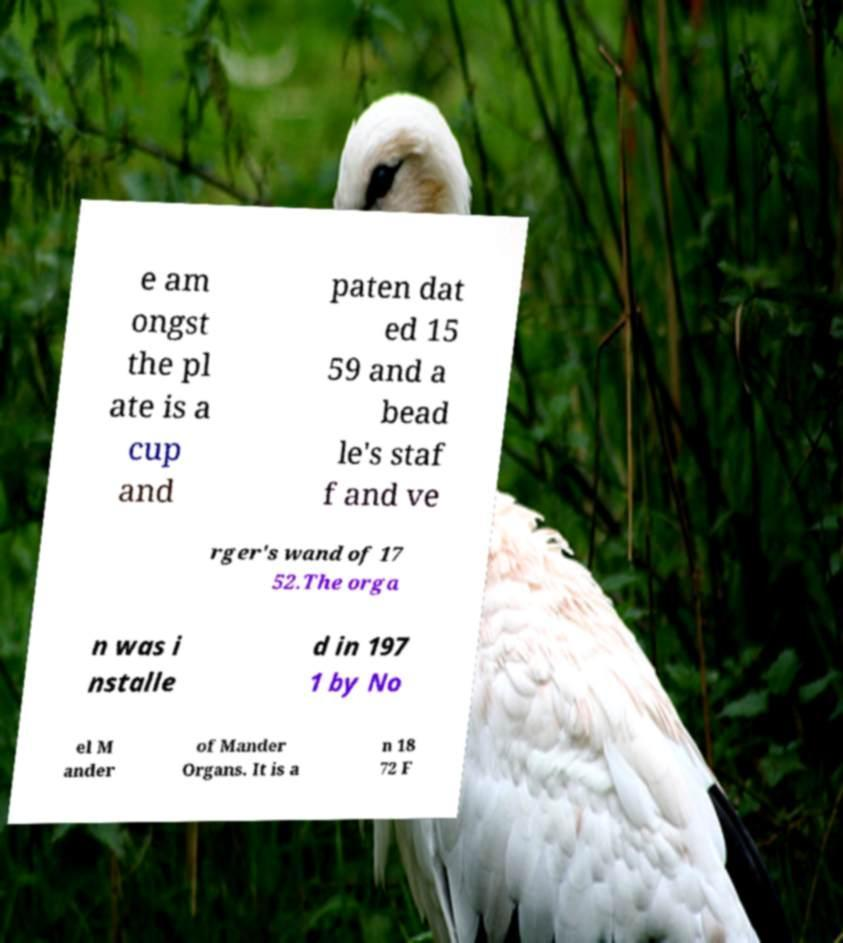Could you extract and type out the text from this image? e am ongst the pl ate is a cup and paten dat ed 15 59 and a bead le's staf f and ve rger's wand of 17 52.The orga n was i nstalle d in 197 1 by No el M ander of Mander Organs. It is a n 18 72 F 